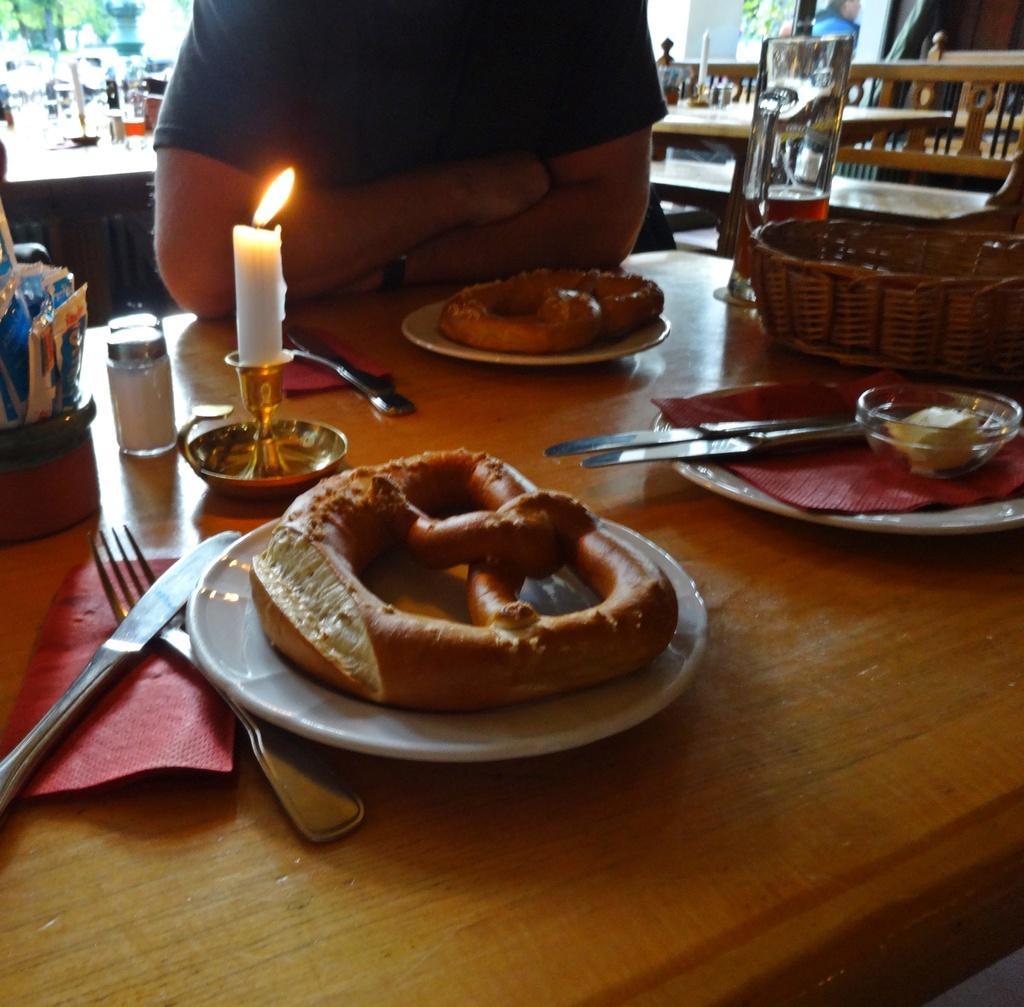Can you describe this image briefly? In this image I can see the brown colored table on which I can see few spoons, few plates, few food items, a candle and few other objects. I can see a person wearing t shirt is in front of the table. In the background I can see few tables, few trees and few other objects. 